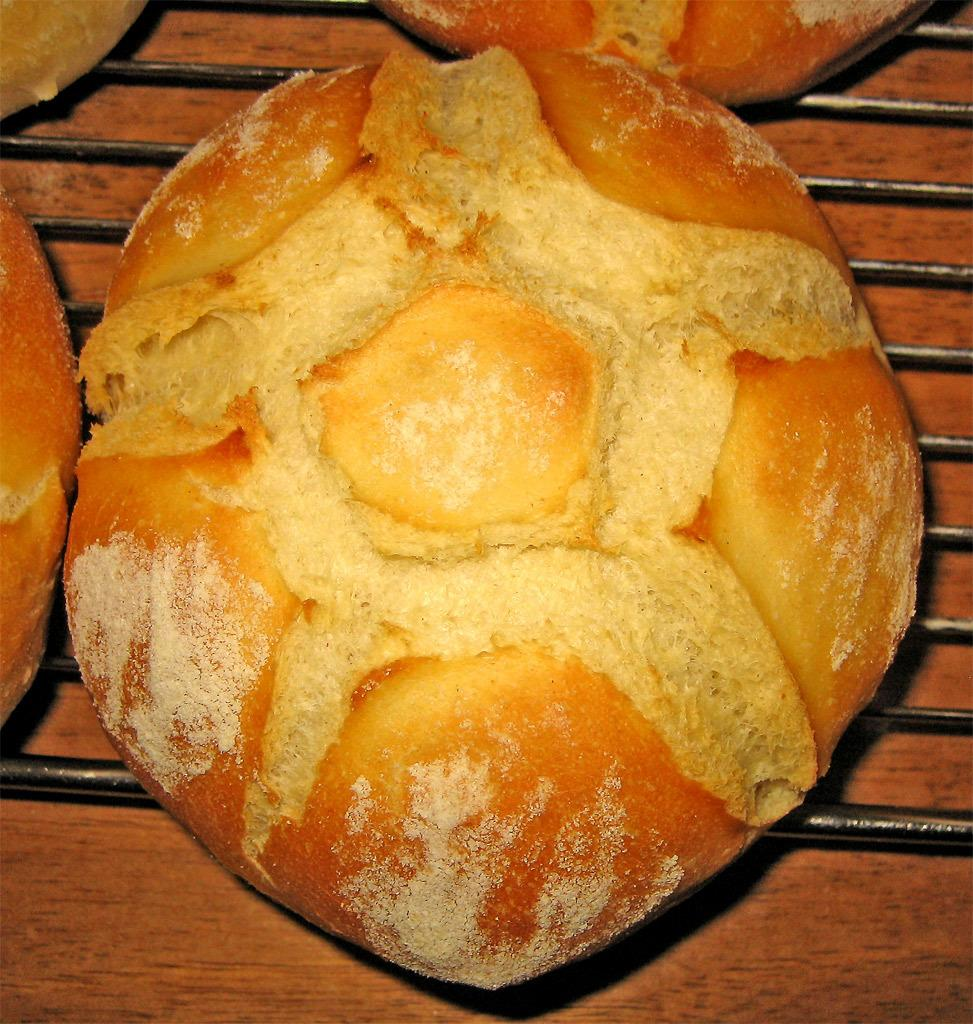What is the color of the grill rods in the image? The grill rods in the image are black. What type of food can be seen on the grill rods? There is brown and cream color food on the grill rods. Are there any hands holding the grill rods in the image? No, there are no hands visible in the image. What type of fish can be seen on the grill rods in the image? There is no fish present in the image; it features brown and cream color food. 